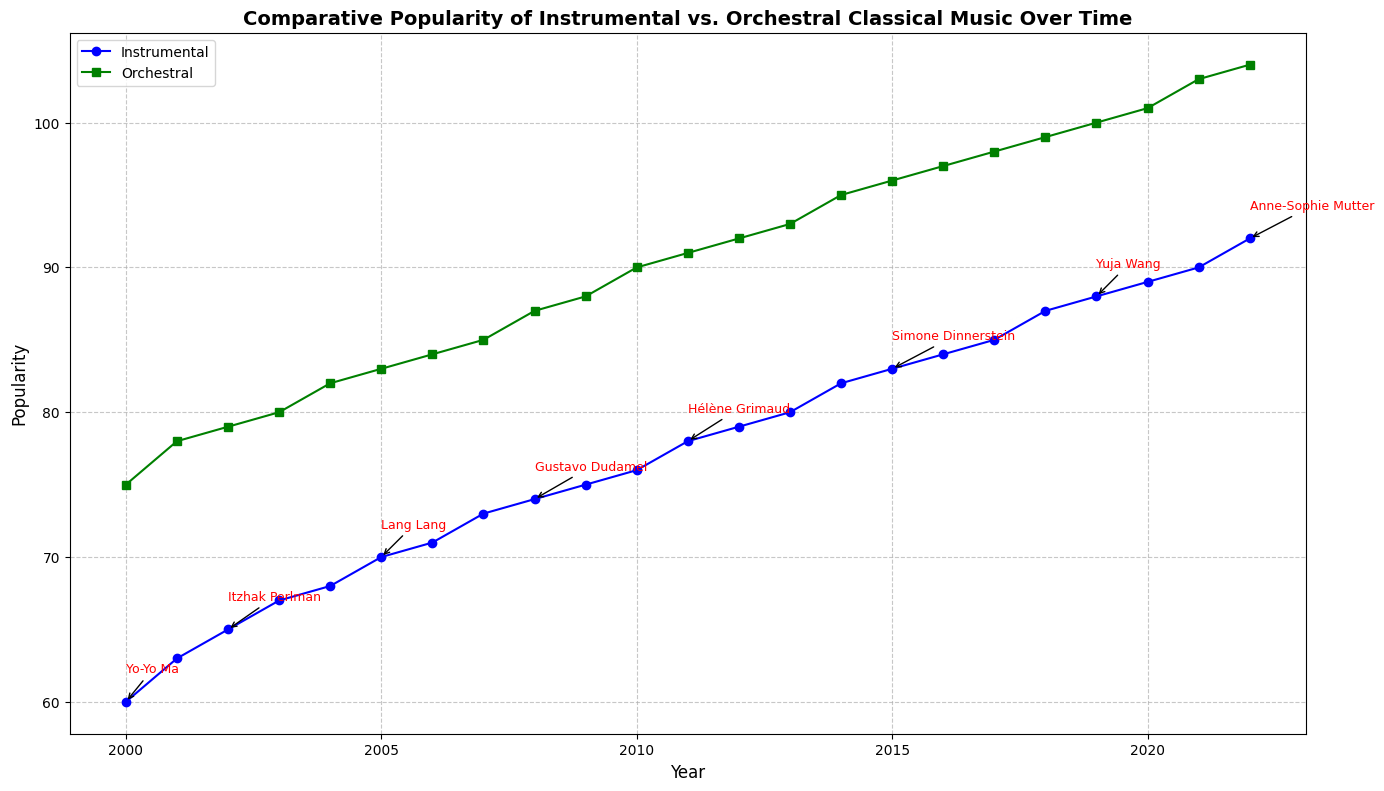What was the overall trend in the popularity of Instrumental classical music from 2000 to 2022? The line chart shows a consistent upward trend in Instrumental classical music popularity, increasing from 60 in 2000 to 92 in 2022.
Answer: Upward During which year did Instrumental classical music and Orchestral classical music share the same influencer, and what were their popularity levels? The influencers are annotated on the chart. In 2022, Anne-Sophie Mutter is highlighted, with Instrumental music at 92 and Orchestral at 104.
Answer: 2022, 92 and 104 Did Orchestral classical music's popularity ever decrease or stay constant from one year to the next? By examining the Orchestral popularity line, it consistently increases every year from 2000 to 2022, without any dips or periods of constancy.
Answer: No Which way did the gap in popularity change between Instrumental and Orchestral classical music from 2000 to 2022? Initially, in 2000, Orchestral music is 15 points more popular (75 vs. 60). By 2022, the gap has widened to 12 points (104 vs. 92). Hence, the gap increased overall.
Answer: Increased Identify the performer who influenced the trend in 2015 and describe its immediate effect on Instrumental music's popularity the subsequent year. In 2015, Simone Dinnerstein is highlighted. Instrumental music's popularity increased from 83 in 2015 to 84 in 2016.
Answer: Simone Dinnerstein, increase by 1 point Compare the popularity of Instrumental and Orchestral classical music in 2019 and explain the difference. In 2019, Instrumental music was at 88, while Orchestral was at 100. The difference is 100 - 88 = 12 points.
Answer: 12 points When did the popularity of Instrumental classical music surpass 80? Examining the Instrumental popularity line, it crosses the 80 mark in 2013.
Answer: 2013 How many influential performers were highlighted during the period from 2000 to 2022? There are 8 annotations on the plot indicating influential performers from 2000 to 2022.
Answer: 8 How did Gustavo Dudamel's influence in 2008 impact Instrumental music popularity? Instrumental popularity increases from 73 in 2007 to 74 in 2008, the year Gustavo Dudamel is highlighted. This indicates a positive impact.
Answer: Increased by 1 point Which genre saw more influence by performers over the years, and how can you tell? The annotations highlight influential performers and their references are alongside Instrumental popularity, indicating more influence in this genre.
Answer: Instrumental 